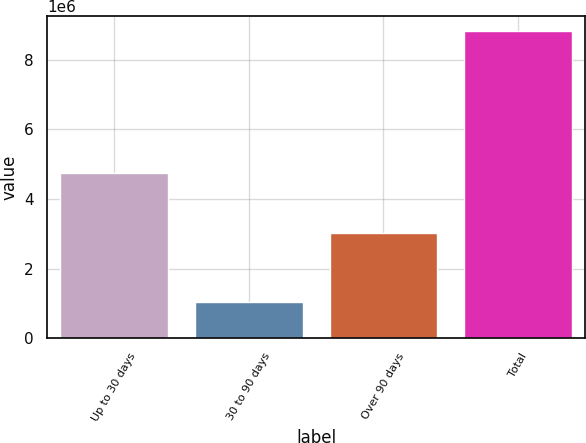Convert chart. <chart><loc_0><loc_0><loc_500><loc_500><bar_chart><fcel>Up to 30 days<fcel>30 to 90 days<fcel>Over 90 days<fcel>Total<nl><fcel>4.7376e+06<fcel>1.05278e+06<fcel>3.02674e+06<fcel>8.81712e+06<nl></chart> 